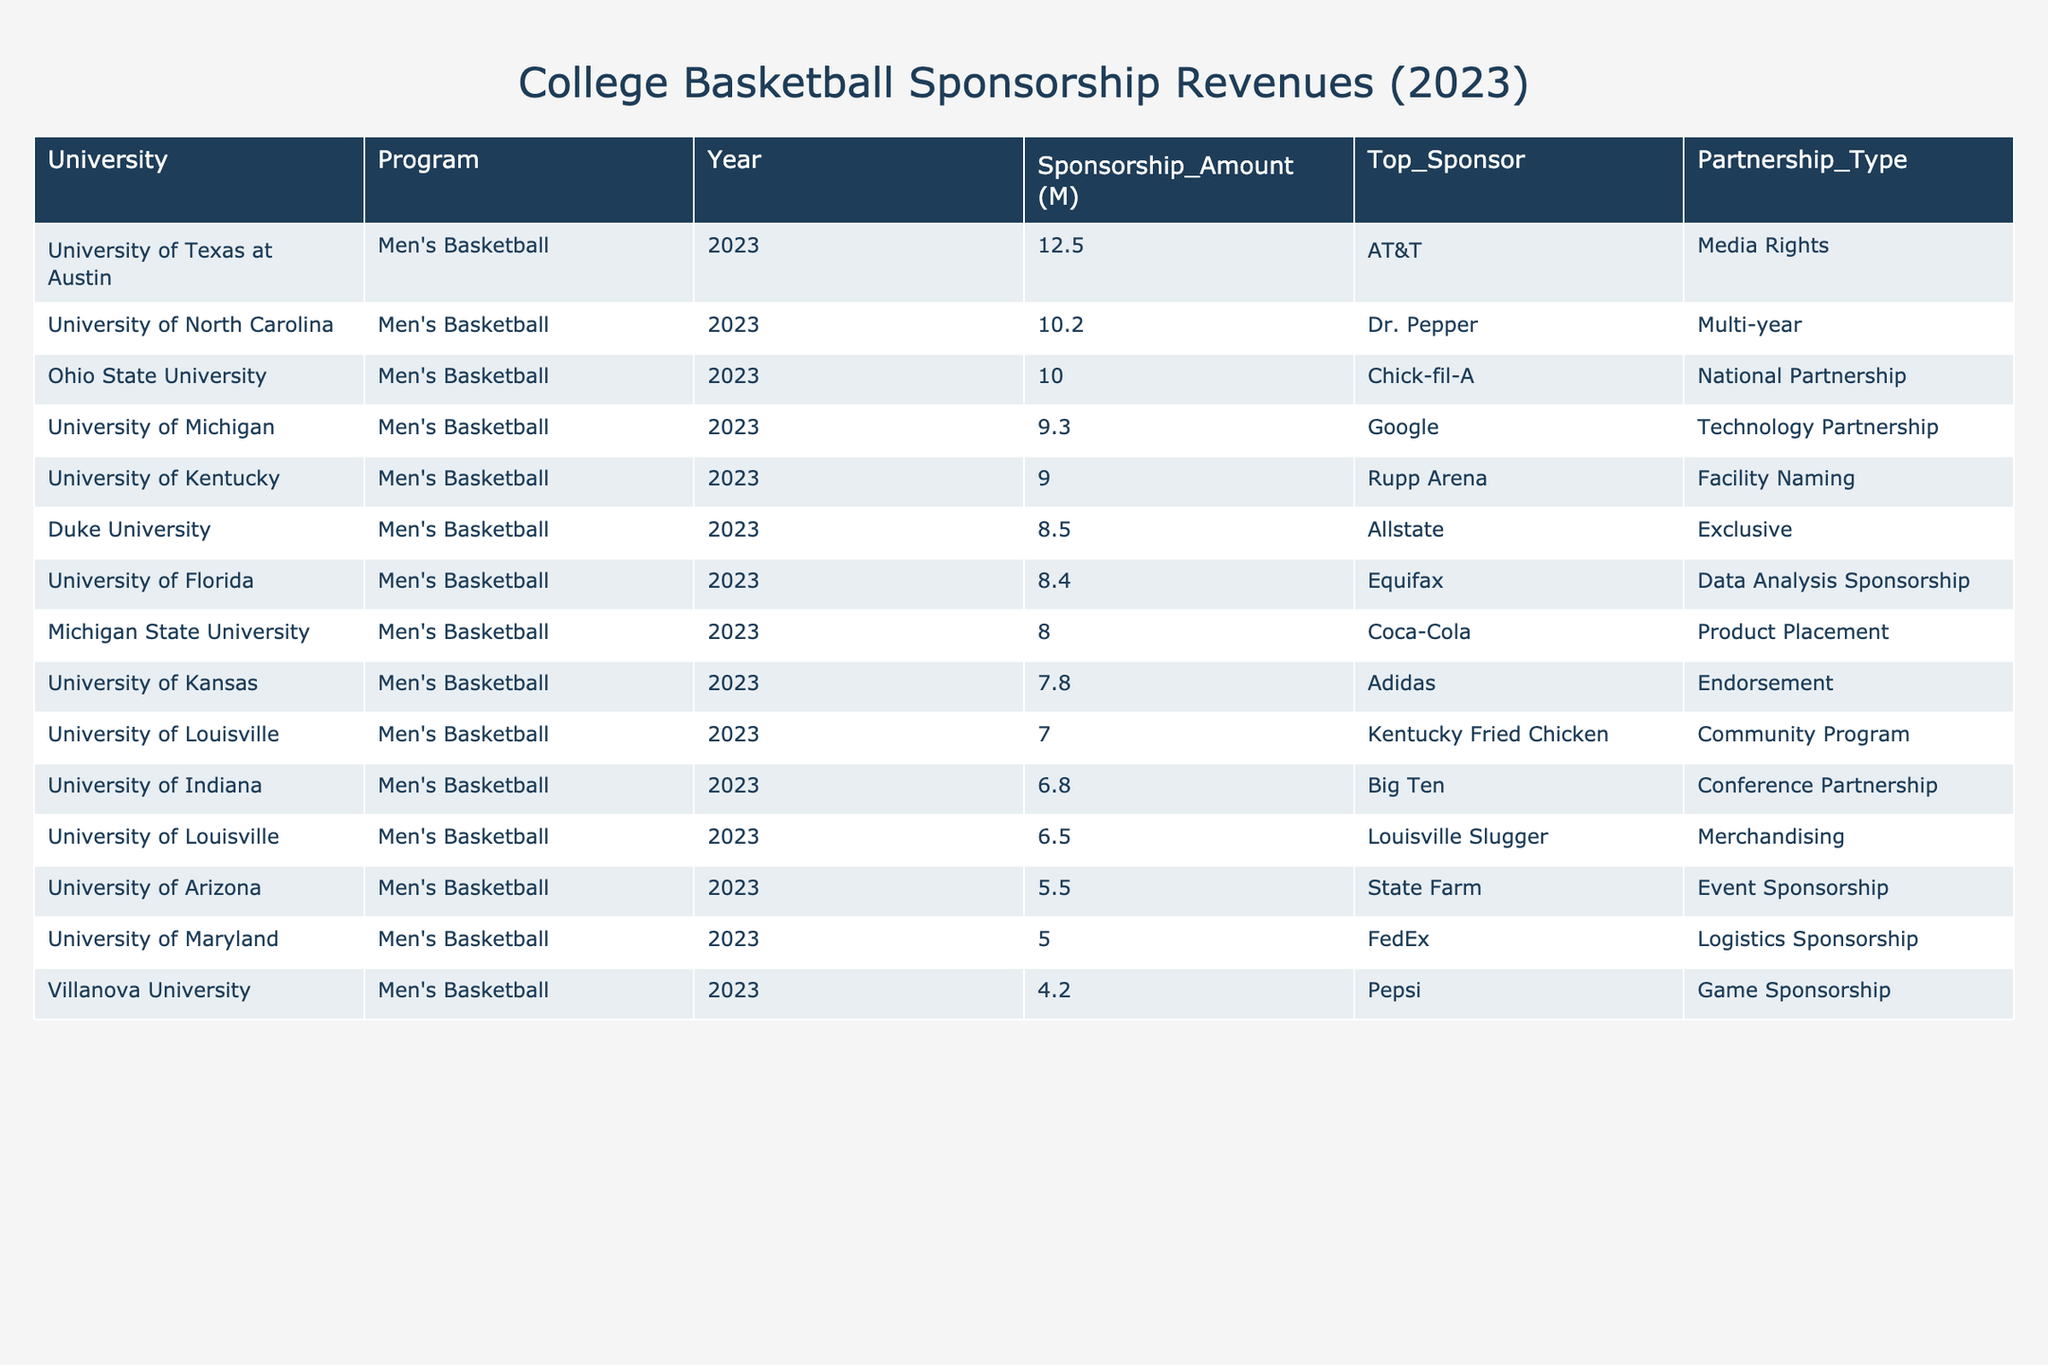What is the highest sponsorship amount among the college basketball programs? The highest sponsorship amount can be found by looking at the "Sponsorship_Amount (M)" column. The highest value listed is 12.5 million dollars from the University of Texas at Austin.
Answer: 12.5 Which university received a sponsorship amount of 10 million or more? By checking the "Sponsorship_Amount (M)" column, the universities that meet this criterion are the University of North Carolina (10.2), University of Texas at Austin (12.5), and Ohio State University (10.0).
Answer: University of North Carolina, University of Texas at Austin, Ohio State University What is the average sponsorship amount for the college basketball programs listed? To calculate the average, sum all the sponsorship amounts (8.5 + 10.2 + 7.8 + 9.0 + 6.5 + 8.0 + 5.5 + 4.2 + 6.8 + 12.5 + 9.3 + 7.0 + 10.0 + 8.4 + 5.0 = 88.3) and divide by the number of programs (15). The average sponsorship amount is 88.3 / 15 = 5.89 million dollars.
Answer: 5.89 Which program had the lowest sponsorship amount in 2023? The lowest sponsorship amount can be identified from the "Sponsorship_Amount (M)" column. The value is 4.2 million dollars from Villanova University.
Answer: Villanova University Is there any program listed with an exclusive partnership? To find out, check the "Partnership_Type" column for the term "Exclusive." Only Duke University has an exclusive partnership with Allstate.
Answer: Yes Which university received sponsorship from AT&T and what was the amount? The table indicates that the University of Texas at Austin received sponsorship from AT&T, amounting to 12.5 million dollars.
Answer: University of Texas at Austin, 12.5 What is the total sponsorship amount for programs associated with community programs? The only program listed under community programs is the University of Louisville, with a sponsorship amount of 7.0 million dollars. Therefore, the total sponsorship amount is 7.0 million dollars.
Answer: 7.0 How many universities received sponsorship from beverage companies? Checking the "Top_Sponsor" column, the relevant universities are Michigan State University (Coca-Cola), Villanova University (Pepsi), and Kentucky Fried Chicken (which offers beverages), totaling 3 universities.
Answer: 3 Which program had a naming rights partnership and what was the sponsor? The "Partnership_Type" column shows that the University of Kentucky had a facility naming partnership with Rupp Arena.
Answer: University of Kentucky, Rupp Arena Calculate the difference between the highest and lowest sponsorship amounts. The highest sponsorship amount is 12.5 million (University of Texas at Austin) and the lowest is 4.2 million (Villanova University). The difference is 12.5 - 4.2 = 8.3 million dollars.
Answer: 8.3 